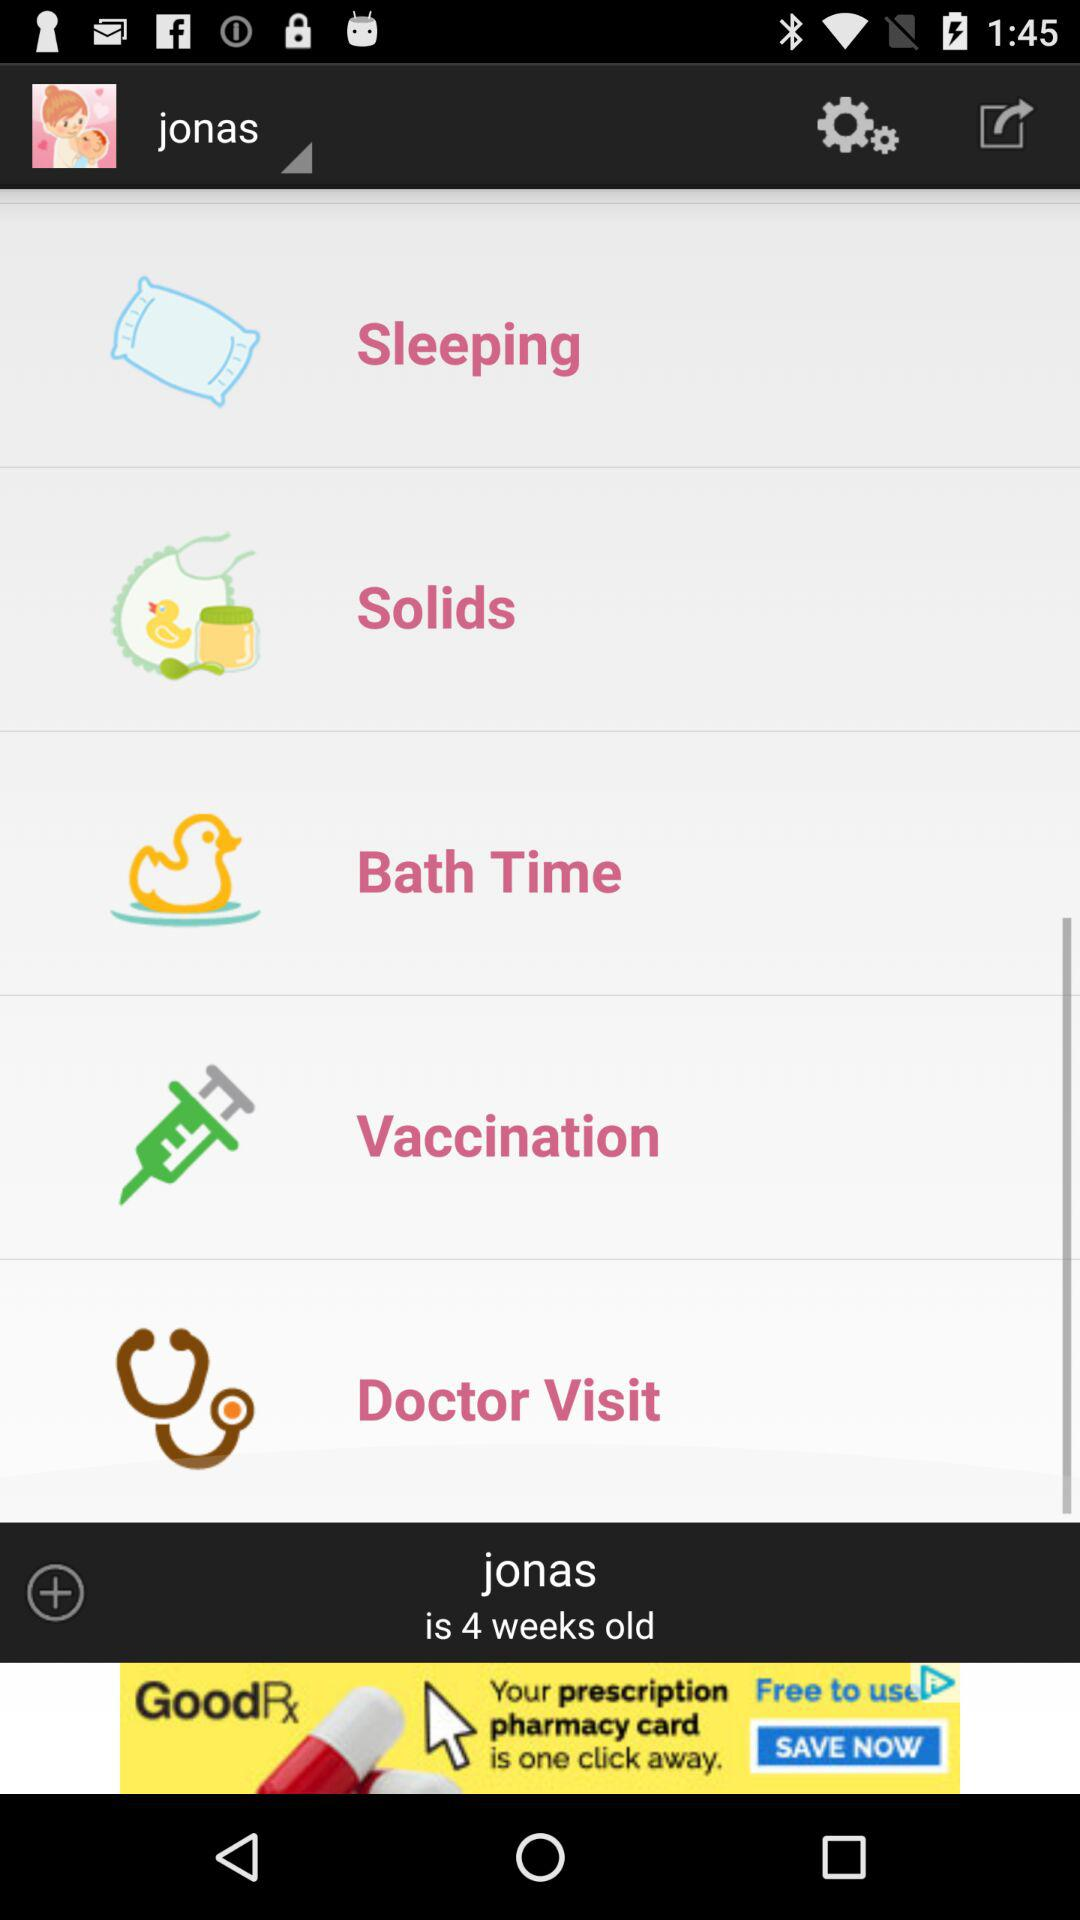What is the age of user? The age of the user is 4 weeks. 